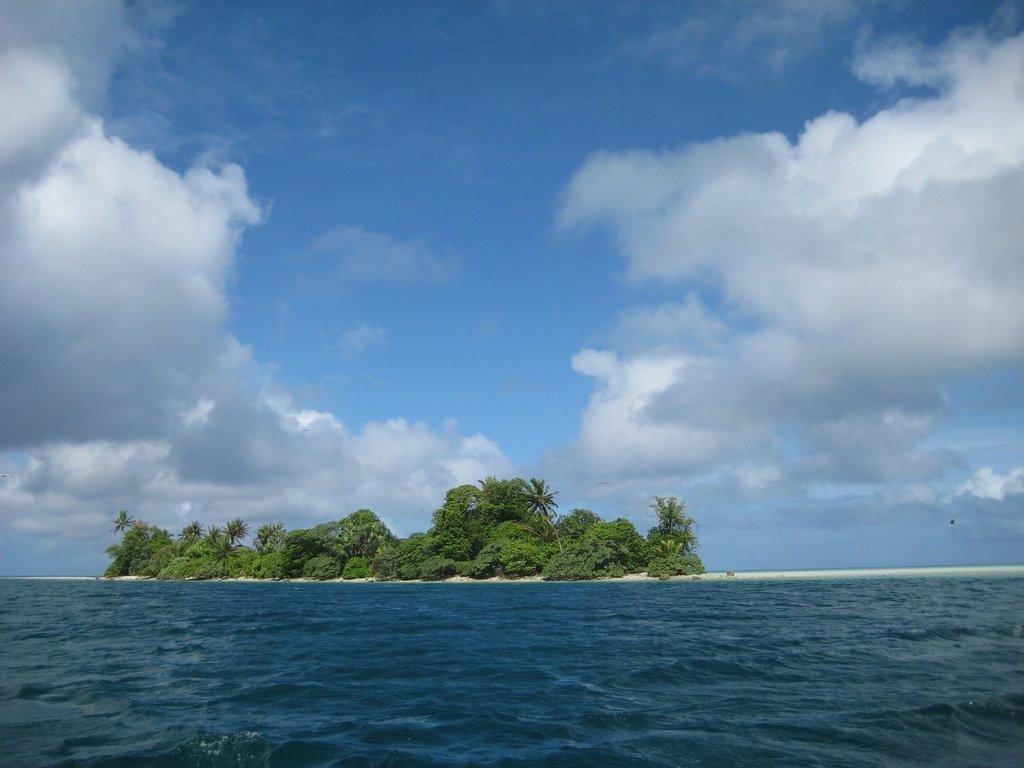What is the main subject of the image? The image depicts a sea. Are there any land features visible in the image? Yes, there are trees on an island in the image. What is visible at the top of the image? The sky is visible at the top of the image. What can be seen in the sky? Clouds are present in the sky. What is visible at the bottom of the image? Water is visible at the bottom of the image. What type of lettuce is being served at the feast on the island in the image? There is no feast or lettuce present in the image; it depicts a sea with an island and trees. Can you describe the stranger walking along the shoreline in the image? There is no stranger or shoreline visible in the image; it only shows a sea, an island with trees, the sky, and clouds. 